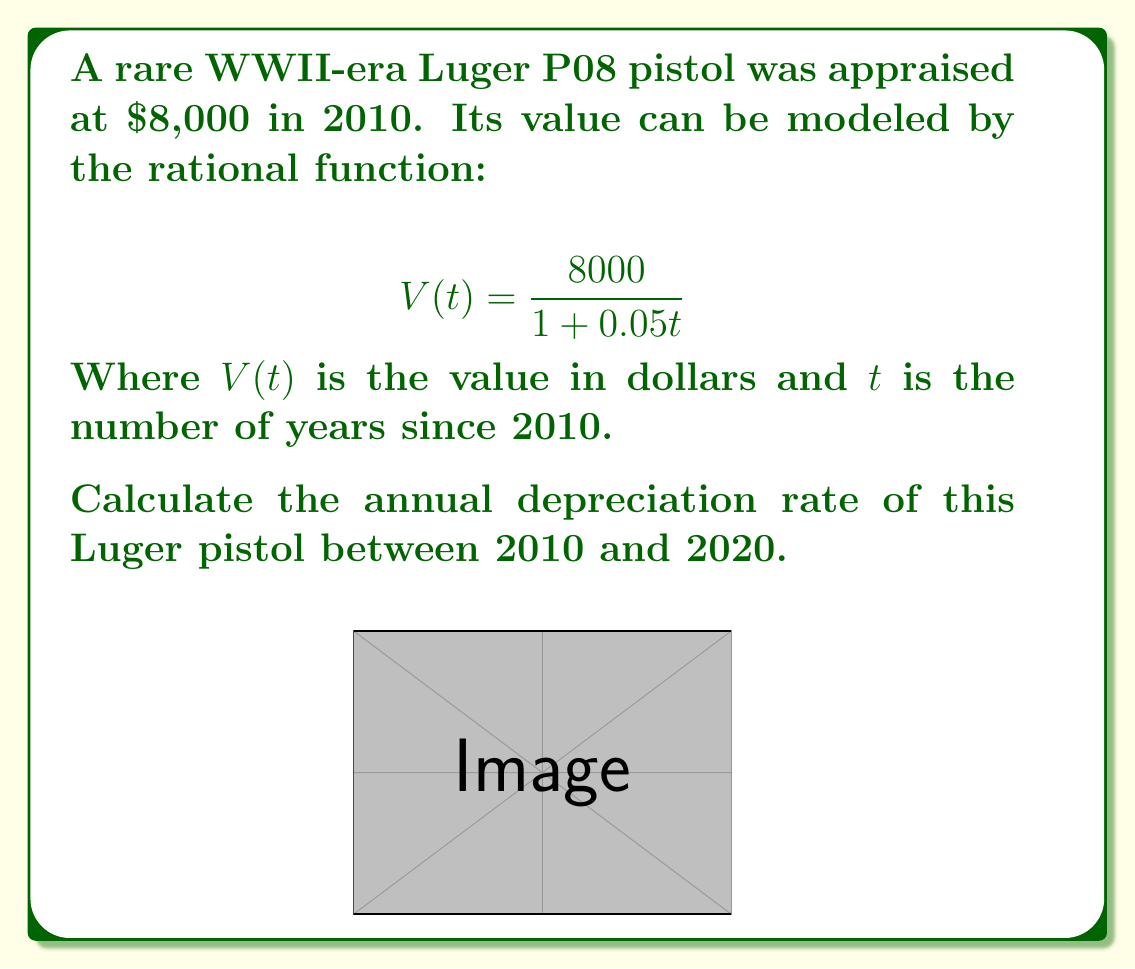Provide a solution to this math problem. To calculate the annual depreciation rate, we need to:

1. Calculate the value in 2010 $(t=0)$ and 2020 $(t=10)$.
2. Determine the total depreciation over 10 years.
3. Calculate the average annual depreciation rate.

Step 1: Calculate values

For 2010 $(t=0)$:
$$V(0) = \frac{8000}{1 + 0.05(0)} = \frac{8000}{1} = 8000$$

For 2020 $(t=10)$:
$$V(10) = \frac{8000}{1 + 0.05(10)} = \frac{8000}{1.5} = 5333.33$$

Step 2: Calculate total depreciation

Total depreciation = $8000 - 5333.33 = 2666.67$

Step 3: Calculate annual depreciation rate

Annual depreciation rate = $\frac{\text{Total depreciation}}{\text{Initial value} \times \text{Number of years}} \times 100\%$

$$\text{Annual depreciation rate} = \frac{2666.67}{8000 \times 10} \times 100\% = 0.0333 \times 100\% = 3.33\%$$

Therefore, the annual depreciation rate of the Luger pistol between 2010 and 2020 is approximately 3.33%.
Answer: 3.33% 